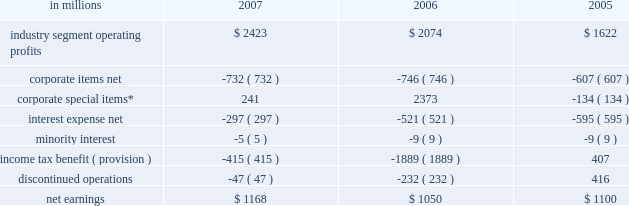Item 7 .
Management 2019s discussion and analysis of financial condition and results of operations executive summary international paper 2019s operating results in 2007 bene- fited from significantly higher paper and packaging price realizations .
Sales volumes were slightly high- er , with growth in overseas markets partially offset by lower volumes in north america as we continued to balance our production with our customers 2019 demand .
Operationally , our pulp and paper and containerboard mills ran very well in 2007 .
However , input costs for wood , energy and transportation costs were all well above 2006 levels .
In our forest products business , earnings decreased 31% ( 31 % ) reflect- ing a sharp decline in harvest income and a smaller drop in forestland and real estate sales , both reflect- ing our forestland divestitures in 2006 .
Interest expense decreased over 40% ( 40 % ) , principally due to lower debt balances and interest rates from debt repayments and refinancings .
Looking forward to the first quarter of 2008 , we expect demand for north american printing papers and packaging to remain steady .
However , if the economic downturn in 2008 is greater than expected , this could have a negative impact on sales volumes and earnings .
Some slight increases in paper and packaging price realizations are expected as we implement our announced price increases .
However , first quarter earnings will reflect increased planned maintenance expenses and continued escalation of wood , energy and transportation costs .
As a result , excluding the impact of projected reduced earnings from land sales and the addition of equity earnings contributions from our recent investment in ilim holding s.a .
In russia , we expect 2008 first-quarter earnings to be lower than in the 2007 fourth quarter .
Results of operations industry segment operating profits are used by inter- national paper 2019s management to measure the earn- ings performance of its businesses .
Management believes that this measure allows a better under- standing of trends in costs , operating efficiencies , prices and volumes .
Industry segment operating profits are defined as earnings before taxes and minority interest , interest expense , corporate items and corporate special items .
Industry segment oper- ating profits are defined by the securities and exchange commission as a non-gaap financial measure , and are not gaap alternatives to net earn- ings or any other operating measure prescribed by accounting principles generally accepted in the united states .
International paper operates in six segments : print- ing papers , industrial packaging , consumer pack- aging , distribution , forest products , and specialty businesses and other .
The table shows the components of net earnings for each of the last three years : in millions 2007 2006 2005 .
* corporate special items include restructuring and other charg- es , net ( gains ) losses on sales and impairments of businesses , gains on transformation plan forestland sales , goodwill impairment charges , insurance recoveries and reversals of reserves no longer required .
Industry segment operating profits of $ 2.4 billion were $ 349 million higher in 2007 than in 2006 due principally to the benefits from higher average price realizations ( $ 461 million ) , the net impact of cost reduction initiatives , improved operating perform- ance and a more favorable mix of products sold ( $ 304 million ) , higher sales volumes ( $ 17 million ) , lower special item costs ( $ 115 million ) and other items ( $ 4 million ) .
These benefits more than offset the impacts of higher energy , raw material and freight costs ( $ 205 million ) , higher costs for planned mill maintenance outages ( $ 48 million ) , lower earn- ings from land sales ( $ 101 million ) , costs at the pensacola mill associated with the conversion of a machine to the production of linerboard ( $ 52 million ) and reduced earnings due to net acquisitions and divestitures ( $ 146 million ) .
Segment operating profit ( in millions ) $ 2074 ( $ 205 ) ( $ 48 ) $ 17 ( $ 244 ) $ 2423$ 4 ( $ 52 ) ( $ 101 ) $ 461 $ 1000 $ 1500 $ 2000 $ 2500 $ 3000 .
What was the average industry segment operating profits from 2005 to 2007? 
Computations: (((1622 + (2423 + 2074)) + 3) / 2)
Answer: 3061.0. 